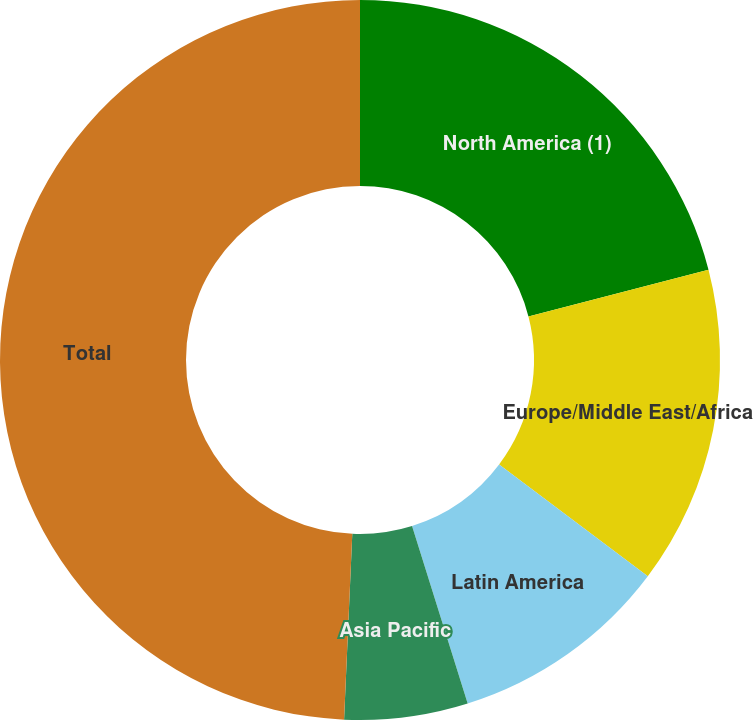<chart> <loc_0><loc_0><loc_500><loc_500><pie_chart><fcel>North America (1)<fcel>Europe/Middle East/Africa<fcel>Latin America<fcel>Asia Pacific<fcel>Total<nl><fcel>20.97%<fcel>14.29%<fcel>9.91%<fcel>5.54%<fcel>49.3%<nl></chart> 